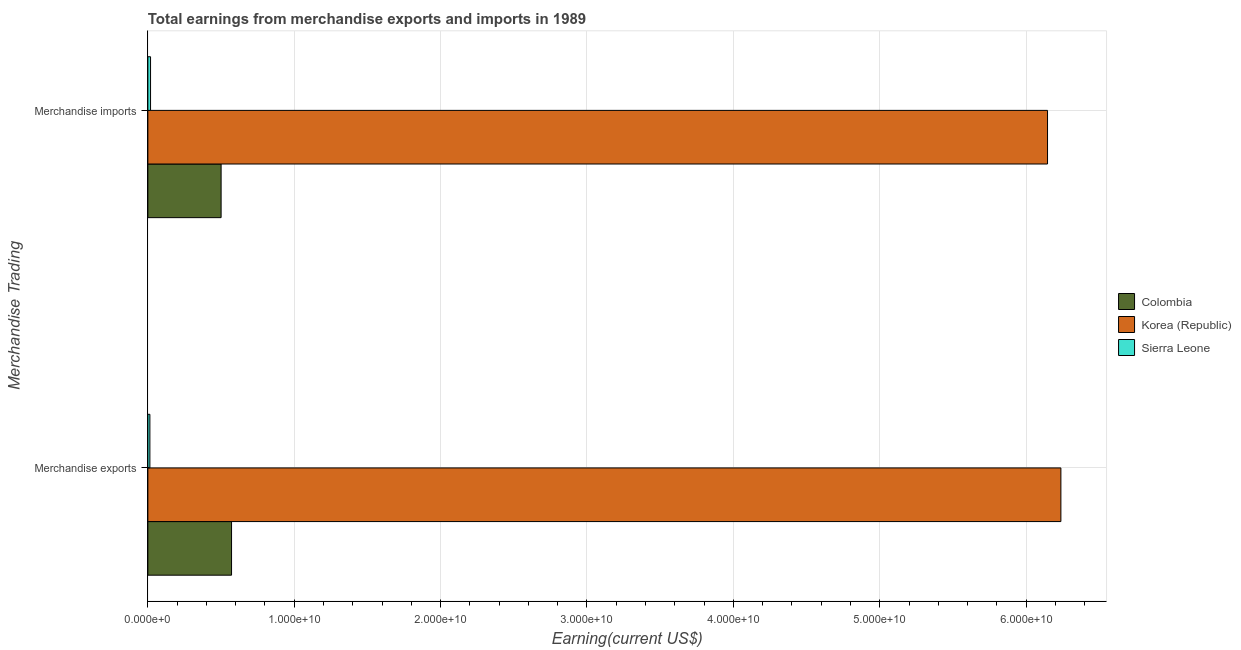How many different coloured bars are there?
Your answer should be very brief. 3. How many groups of bars are there?
Your answer should be compact. 2. Are the number of bars per tick equal to the number of legend labels?
Your response must be concise. Yes. How many bars are there on the 2nd tick from the top?
Your answer should be compact. 3. What is the label of the 2nd group of bars from the top?
Your answer should be very brief. Merchandise exports. What is the earnings from merchandise exports in Colombia?
Keep it short and to the point. 5.72e+09. Across all countries, what is the maximum earnings from merchandise exports?
Keep it short and to the point. 6.24e+1. Across all countries, what is the minimum earnings from merchandise imports?
Provide a succinct answer. 1.83e+08. In which country was the earnings from merchandise exports minimum?
Offer a terse response. Sierra Leone. What is the total earnings from merchandise exports in the graph?
Provide a succinct answer. 6.82e+1. What is the difference between the earnings from merchandise imports in Korea (Republic) and that in Colombia?
Your answer should be compact. 5.65e+1. What is the difference between the earnings from merchandise imports in Korea (Republic) and the earnings from merchandise exports in Sierra Leone?
Your response must be concise. 6.13e+1. What is the average earnings from merchandise exports per country?
Your answer should be compact. 2.27e+1. What is the difference between the earnings from merchandise imports and earnings from merchandise exports in Colombia?
Provide a short and direct response. -7.13e+08. What is the ratio of the earnings from merchandise exports in Korea (Republic) to that in Colombia?
Your answer should be very brief. 10.91. In how many countries, is the earnings from merchandise exports greater than the average earnings from merchandise exports taken over all countries?
Provide a short and direct response. 1. What does the 1st bar from the bottom in Merchandise imports represents?
Provide a succinct answer. Colombia. How many bars are there?
Provide a short and direct response. 6. Are all the bars in the graph horizontal?
Your answer should be compact. Yes. What is the difference between two consecutive major ticks on the X-axis?
Your answer should be very brief. 1.00e+1. Does the graph contain grids?
Provide a succinct answer. Yes. How many legend labels are there?
Make the answer very short. 3. What is the title of the graph?
Offer a very short reply. Total earnings from merchandise exports and imports in 1989. What is the label or title of the X-axis?
Make the answer very short. Earning(current US$). What is the label or title of the Y-axis?
Make the answer very short. Merchandise Trading. What is the Earning(current US$) in Colombia in Merchandise exports?
Ensure brevity in your answer.  5.72e+09. What is the Earning(current US$) of Korea (Republic) in Merchandise exports?
Make the answer very short. 6.24e+1. What is the Earning(current US$) of Sierra Leone in Merchandise exports?
Provide a succinct answer. 1.38e+08. What is the Earning(current US$) in Colombia in Merchandise imports?
Give a very brief answer. 5.00e+09. What is the Earning(current US$) in Korea (Republic) in Merchandise imports?
Your answer should be compact. 6.15e+1. What is the Earning(current US$) in Sierra Leone in Merchandise imports?
Offer a terse response. 1.83e+08. Across all Merchandise Trading, what is the maximum Earning(current US$) of Colombia?
Give a very brief answer. 5.72e+09. Across all Merchandise Trading, what is the maximum Earning(current US$) of Korea (Republic)?
Your response must be concise. 6.24e+1. Across all Merchandise Trading, what is the maximum Earning(current US$) in Sierra Leone?
Your response must be concise. 1.83e+08. Across all Merchandise Trading, what is the minimum Earning(current US$) in Colombia?
Your answer should be compact. 5.00e+09. Across all Merchandise Trading, what is the minimum Earning(current US$) of Korea (Republic)?
Provide a short and direct response. 6.15e+1. Across all Merchandise Trading, what is the minimum Earning(current US$) of Sierra Leone?
Provide a short and direct response. 1.38e+08. What is the total Earning(current US$) in Colombia in the graph?
Offer a terse response. 1.07e+1. What is the total Earning(current US$) in Korea (Republic) in the graph?
Your answer should be compact. 1.24e+11. What is the total Earning(current US$) in Sierra Leone in the graph?
Keep it short and to the point. 3.21e+08. What is the difference between the Earning(current US$) of Colombia in Merchandise exports and that in Merchandise imports?
Offer a terse response. 7.13e+08. What is the difference between the Earning(current US$) in Korea (Republic) in Merchandise exports and that in Merchandise imports?
Your answer should be very brief. 9.12e+08. What is the difference between the Earning(current US$) in Sierra Leone in Merchandise exports and that in Merchandise imports?
Keep it short and to the point. -4.50e+07. What is the difference between the Earning(current US$) of Colombia in Merchandise exports and the Earning(current US$) of Korea (Republic) in Merchandise imports?
Provide a succinct answer. -5.57e+1. What is the difference between the Earning(current US$) in Colombia in Merchandise exports and the Earning(current US$) in Sierra Leone in Merchandise imports?
Provide a short and direct response. 5.53e+09. What is the difference between the Earning(current US$) of Korea (Republic) in Merchandise exports and the Earning(current US$) of Sierra Leone in Merchandise imports?
Provide a succinct answer. 6.22e+1. What is the average Earning(current US$) of Colombia per Merchandise Trading?
Keep it short and to the point. 5.36e+09. What is the average Earning(current US$) of Korea (Republic) per Merchandise Trading?
Your answer should be very brief. 6.19e+1. What is the average Earning(current US$) in Sierra Leone per Merchandise Trading?
Give a very brief answer. 1.60e+08. What is the difference between the Earning(current US$) of Colombia and Earning(current US$) of Korea (Republic) in Merchandise exports?
Your response must be concise. -5.67e+1. What is the difference between the Earning(current US$) in Colombia and Earning(current US$) in Sierra Leone in Merchandise exports?
Provide a short and direct response. 5.58e+09. What is the difference between the Earning(current US$) in Korea (Republic) and Earning(current US$) in Sierra Leone in Merchandise exports?
Make the answer very short. 6.22e+1. What is the difference between the Earning(current US$) of Colombia and Earning(current US$) of Korea (Republic) in Merchandise imports?
Your answer should be very brief. -5.65e+1. What is the difference between the Earning(current US$) of Colombia and Earning(current US$) of Sierra Leone in Merchandise imports?
Your response must be concise. 4.82e+09. What is the difference between the Earning(current US$) of Korea (Republic) and Earning(current US$) of Sierra Leone in Merchandise imports?
Your response must be concise. 6.13e+1. What is the ratio of the Earning(current US$) in Colombia in Merchandise exports to that in Merchandise imports?
Your answer should be very brief. 1.14. What is the ratio of the Earning(current US$) in Korea (Republic) in Merchandise exports to that in Merchandise imports?
Provide a short and direct response. 1.01. What is the ratio of the Earning(current US$) of Sierra Leone in Merchandise exports to that in Merchandise imports?
Keep it short and to the point. 0.75. What is the difference between the highest and the second highest Earning(current US$) of Colombia?
Provide a short and direct response. 7.13e+08. What is the difference between the highest and the second highest Earning(current US$) of Korea (Republic)?
Ensure brevity in your answer.  9.12e+08. What is the difference between the highest and the second highest Earning(current US$) in Sierra Leone?
Offer a very short reply. 4.50e+07. What is the difference between the highest and the lowest Earning(current US$) of Colombia?
Keep it short and to the point. 7.13e+08. What is the difference between the highest and the lowest Earning(current US$) in Korea (Republic)?
Your response must be concise. 9.12e+08. What is the difference between the highest and the lowest Earning(current US$) in Sierra Leone?
Make the answer very short. 4.50e+07. 